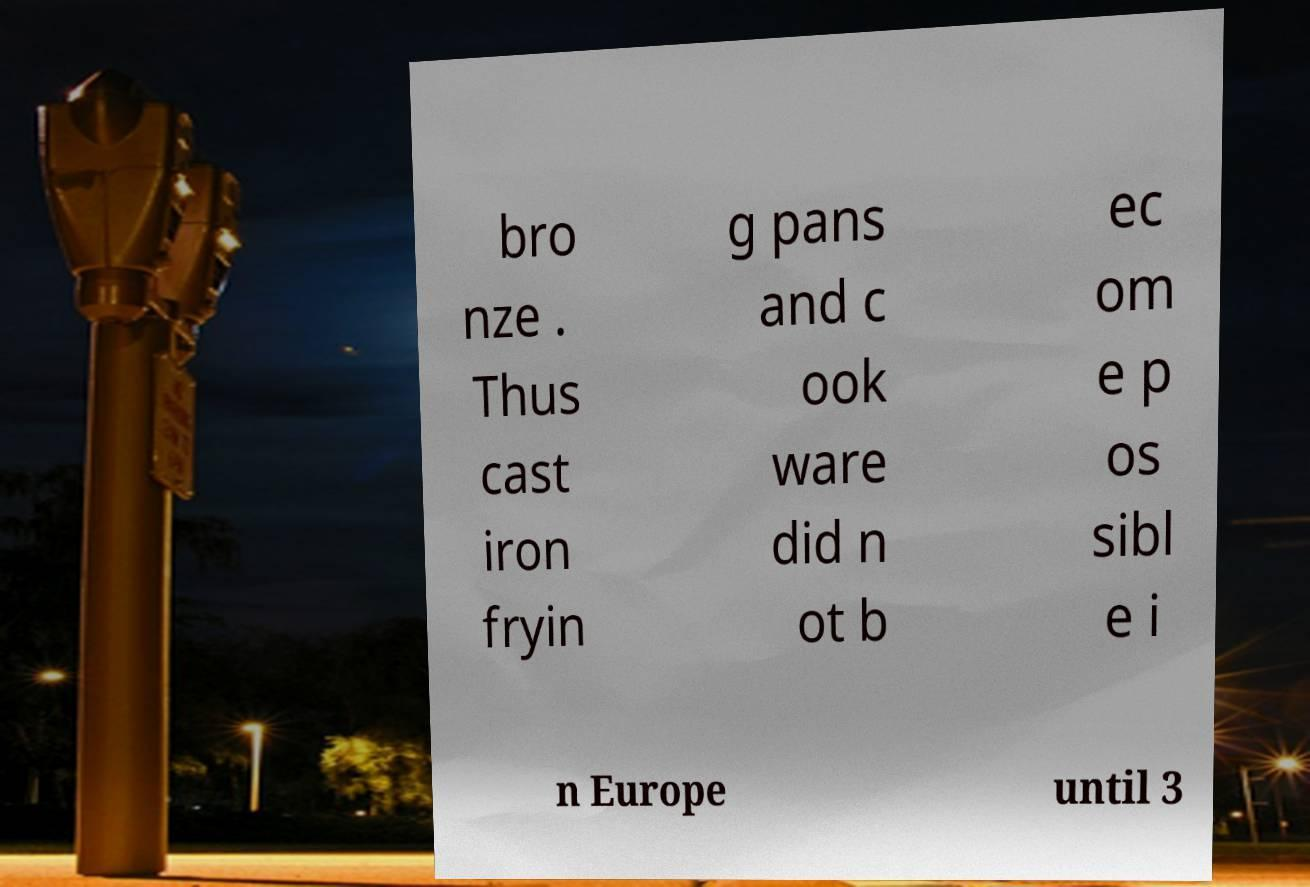For documentation purposes, I need the text within this image transcribed. Could you provide that? bro nze . Thus cast iron fryin g pans and c ook ware did n ot b ec om e p os sibl e i n Europe until 3 